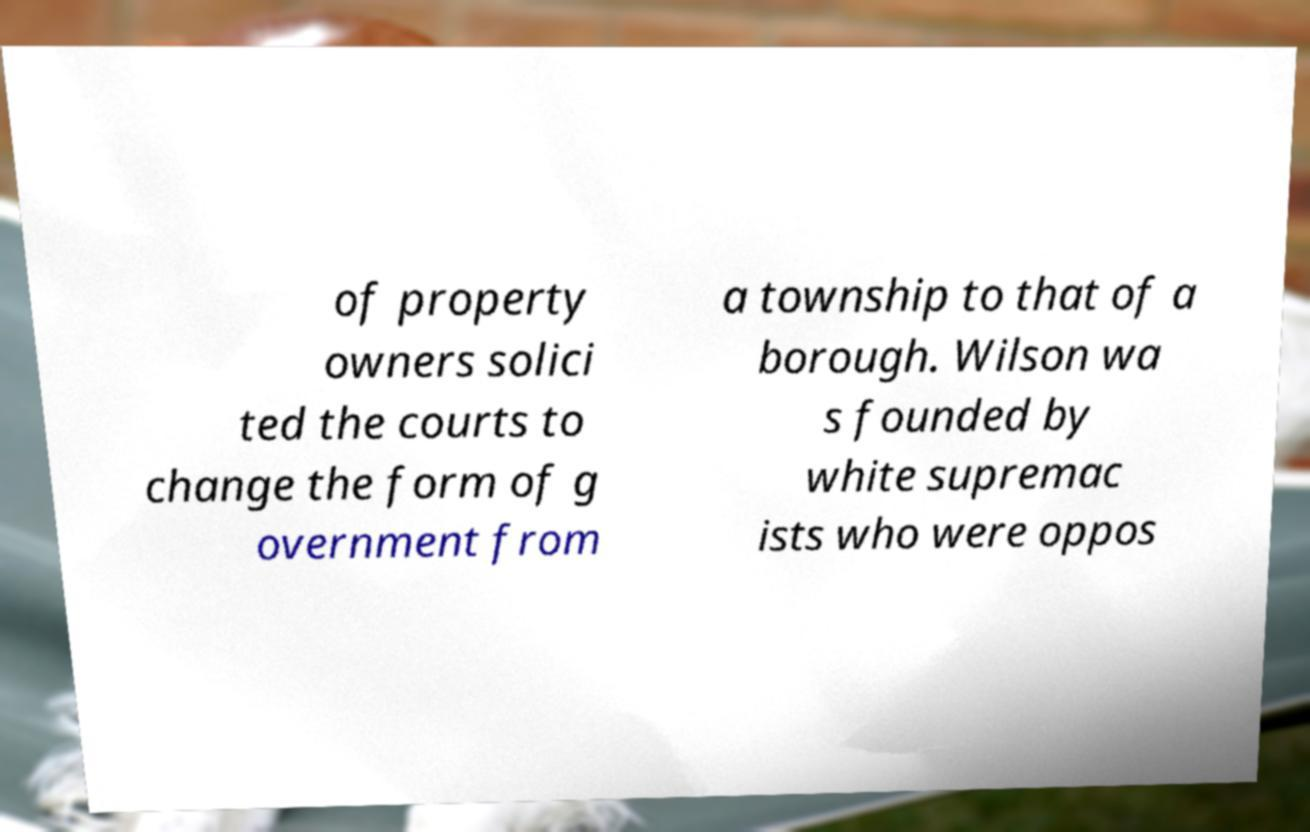Could you assist in decoding the text presented in this image and type it out clearly? of property owners solici ted the courts to change the form of g overnment from a township to that of a borough. Wilson wa s founded by white supremac ists who were oppos 